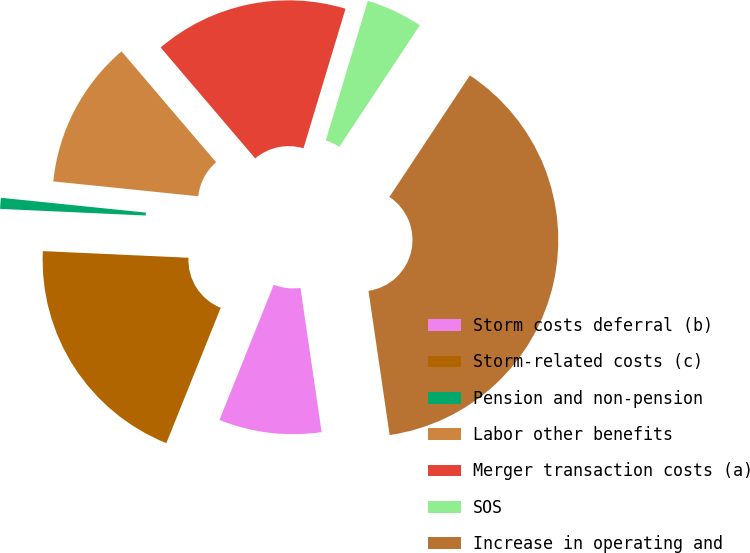Convert chart to OTSL. <chart><loc_0><loc_0><loc_500><loc_500><pie_chart><fcel>Storm costs deferral (b)<fcel>Storm-related costs (c)<fcel>Pension and non-pension<fcel>Labor other benefits<fcel>Merger transaction costs (a)<fcel>SOS<fcel>Increase in operating and<nl><fcel>8.4%<fcel>19.64%<fcel>0.9%<fcel>12.14%<fcel>15.89%<fcel>4.65%<fcel>38.37%<nl></chart> 